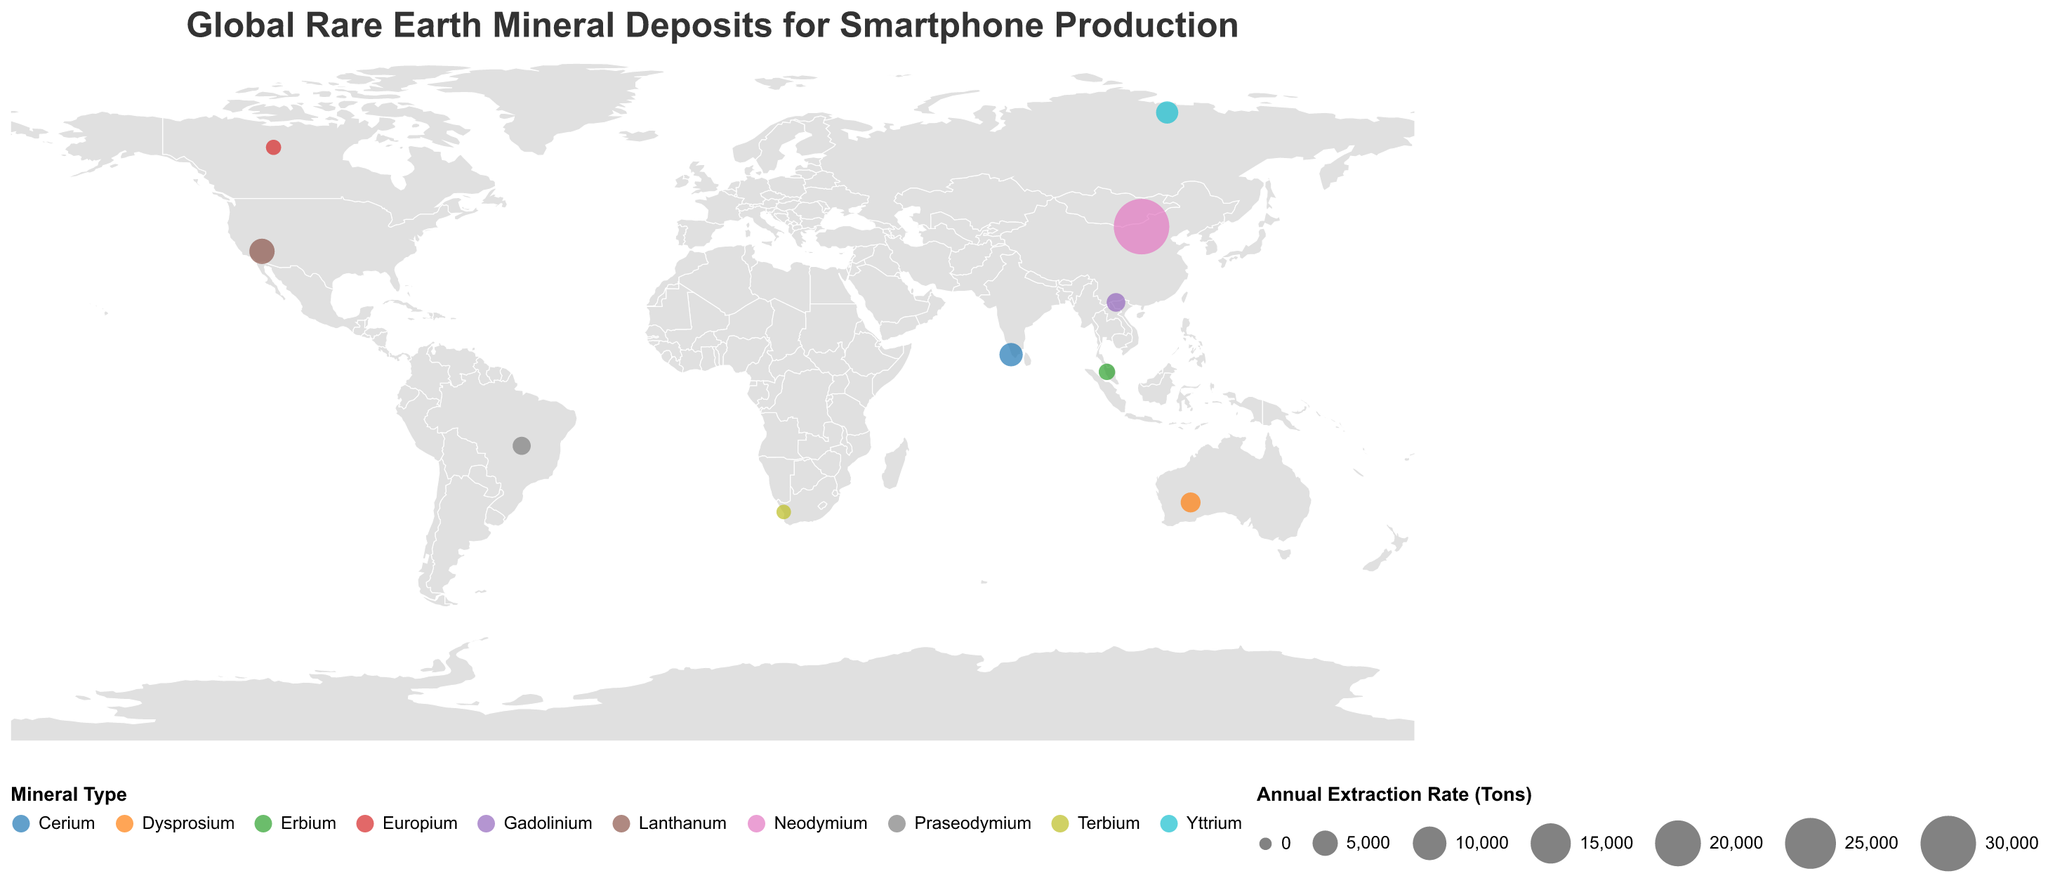What is the title of the figure? The title is usually displayed at the top of the figure to denote the subject being visualized. Here, the title is "Global Rare Earth Mineral Deposits for Smartphone Production".
Answer: Global Rare Earth Mineral Deposits for Smartphone Production Which country has the largest annual extraction rate of rare earth minerals? The size of the circles represents the annual extraction rate of rare earth minerals. The largest circle is over China with an annual extraction rate of 30,000 tons.
Answer: China Which mineral is extracted in the highest quantity annually? By comparing the sizes of the circles within the figure, the mineral with the largest circle is Neodymium, extracted in China at 30,000 tons annually.
Answer: Neodymium How does the annual extraction rate of Cerium in India compare with that of Gadolinium in Vietnam? The circles representing Cerium (India) and Gadolinium (Vietnam) show extraction rates of 4,000 tons and 2,000 tons, respectively. Cerium's extraction rate is double that of Gadolinium.
Answer: Cerium is higher What's the total annual extraction rate of all the minerals combined? Sum the extraction rates given for each country: 30,000 (China) + 2,500 (Australia) + 5,000 (USA) + 1,800 (Brazil) + 3,500 (Russia) + 4,000 (India) + 800 (Canada) + 600 (South Africa) + 1,200 (Malaysia) + 2,000 (Vietnam) = 51,400 tons.
Answer: 51,400 tons Which continent has the highest diversity of rare earth minerals based on the map? Africa, Asia, North America, and Australia are represented. Asia shows extraction of Neodymium, Cerium, Erbium, and Gadolinium, indicating it has the highest diversity of minerals.
Answer: Asia What is the geographic location (longitude and latitude) with the lowest annual extraction rate? The smallest circle on the map, representing the lowest extraction rate, is located at Steenkampskraal, South Africa, with coordinates (18.2333, -31.3167).
Answer: 18.2333, -31.3167 Compare the extraction rates of Europium in Canada and Terbium in South Africa. Which is greater? Europium in Canada has an extraction rate of 800 tons, while Terbium in South Africa has an extraction rate of 600 tons. Europium has a higher extraction rate.
Answer: Europium in Canada What's the median annual extraction rate of all the countries listed? Arrange the extraction rates in ascending order: 600, 800, 1200, 1800, 2000, 2500, 3500, 4000, 5000, 30000. The median value (middle value) between the 5th and 6th numbers is (2000+2500)/2 = 2250 tons.
Answer: 2250 tons 